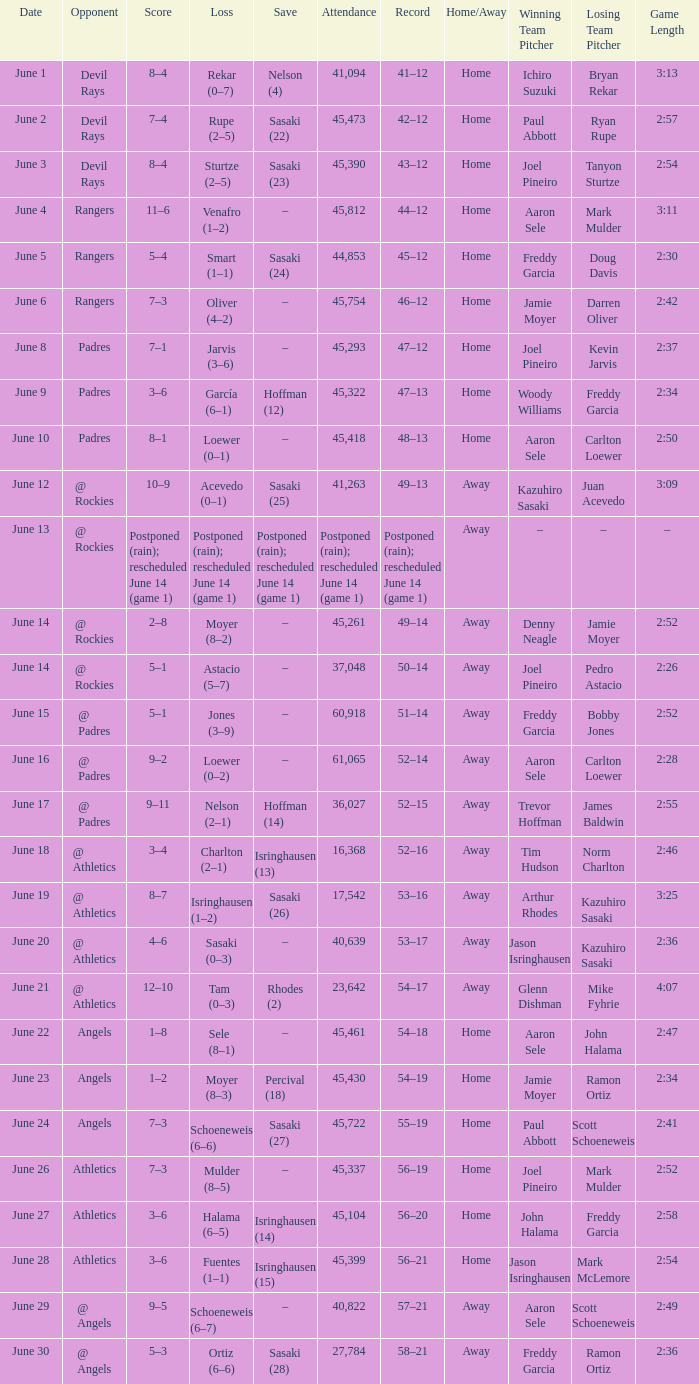What was the attendance of the Mariners game when they had a record of 56–20? 45104.0. 